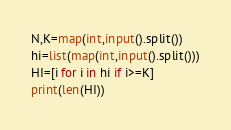<code> <loc_0><loc_0><loc_500><loc_500><_Python_>N,K=map(int,input().split())
hi=list(map(int,input().split()))
HI=[i for i in hi if i>=K]
print(len(HI))</code> 